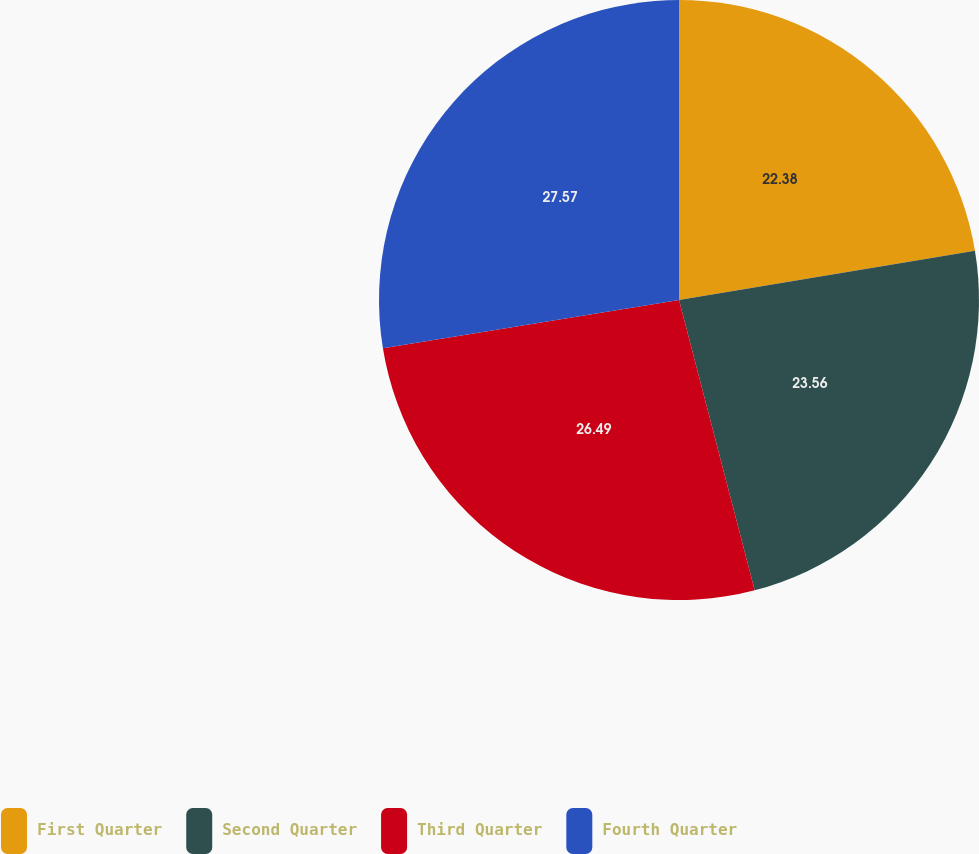Convert chart to OTSL. <chart><loc_0><loc_0><loc_500><loc_500><pie_chart><fcel>First Quarter<fcel>Second Quarter<fcel>Third Quarter<fcel>Fourth Quarter<nl><fcel>22.38%<fcel>23.56%<fcel>26.49%<fcel>27.57%<nl></chart> 